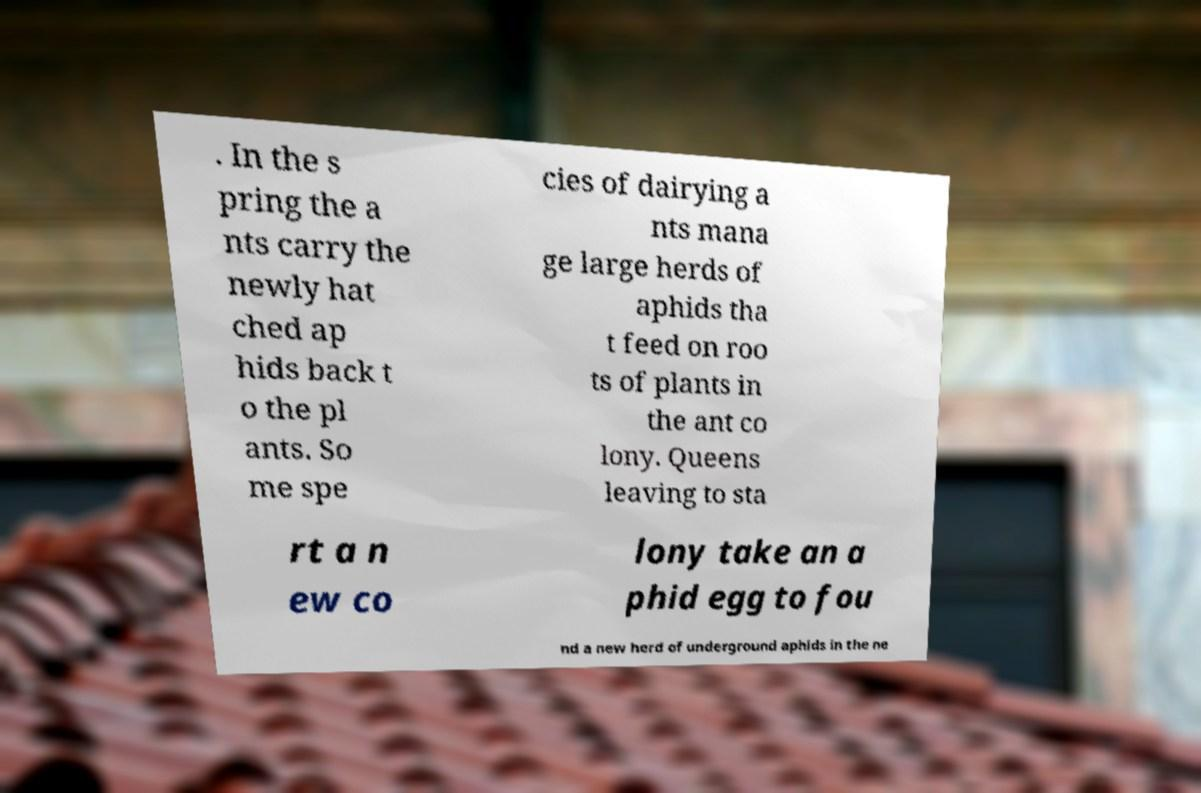Could you assist in decoding the text presented in this image and type it out clearly? . In the s pring the a nts carry the newly hat ched ap hids back t o the pl ants. So me spe cies of dairying a nts mana ge large herds of aphids tha t feed on roo ts of plants in the ant co lony. Queens leaving to sta rt a n ew co lony take an a phid egg to fou nd a new herd of underground aphids in the ne 